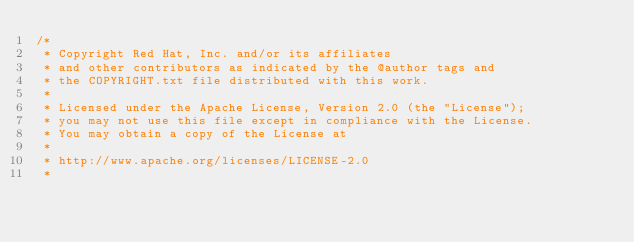Convert code to text. <code><loc_0><loc_0><loc_500><loc_500><_Java_>/*
 * Copyright Red Hat, Inc. and/or its affiliates
 * and other contributors as indicated by the @author tags and
 * the COPYRIGHT.txt file distributed with this work.
 *
 * Licensed under the Apache License, Version 2.0 (the "License");
 * you may not use this file except in compliance with the License.
 * You may obtain a copy of the License at
 *
 * http://www.apache.org/licenses/LICENSE-2.0
 *</code> 